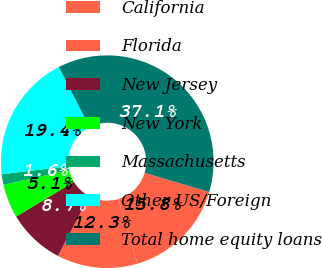Convert chart to OTSL. <chart><loc_0><loc_0><loc_500><loc_500><pie_chart><fcel>California<fcel>Florida<fcel>New Jersey<fcel>New York<fcel>Massachusetts<fcel>Other US/Foreign<fcel>Total home equity loans<nl><fcel>15.81%<fcel>12.26%<fcel>8.7%<fcel>5.15%<fcel>1.6%<fcel>19.36%<fcel>37.13%<nl></chart> 